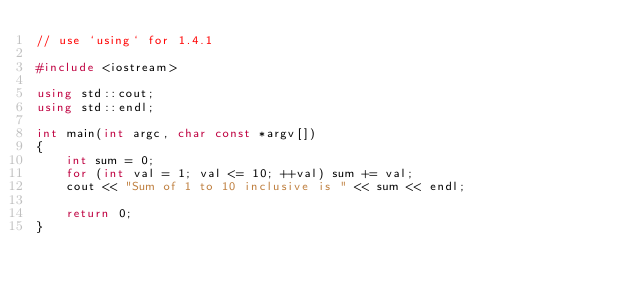<code> <loc_0><loc_0><loc_500><loc_500><_C++_>// use `using` for 1.4.1

#include <iostream>

using std::cout;
using std::endl;

int main(int argc, char const *argv[])
{
    int sum = 0;
    for (int val = 1; val <= 10; ++val) sum += val;
    cout << "Sum of 1 to 10 inclusive is " << sum << endl;

    return 0;
}
</code> 